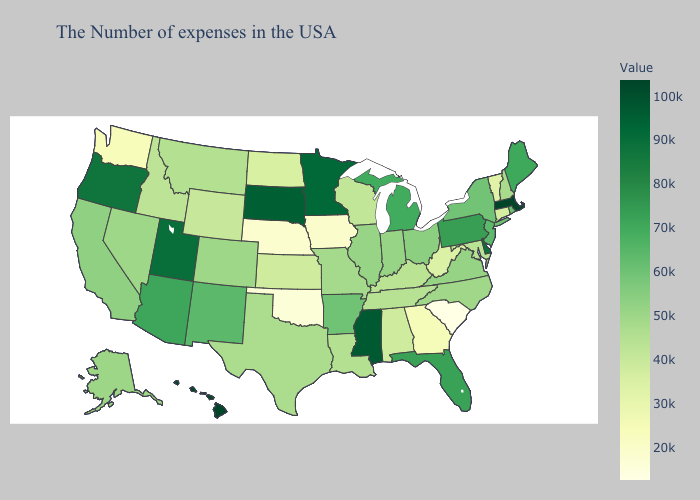Among the states that border Utah , which have the lowest value?
Short answer required. Wyoming. Among the states that border North Dakota , which have the highest value?
Quick response, please. South Dakota. Does New York have the highest value in the Northeast?
Short answer required. No. Does the map have missing data?
Quick response, please. No. 